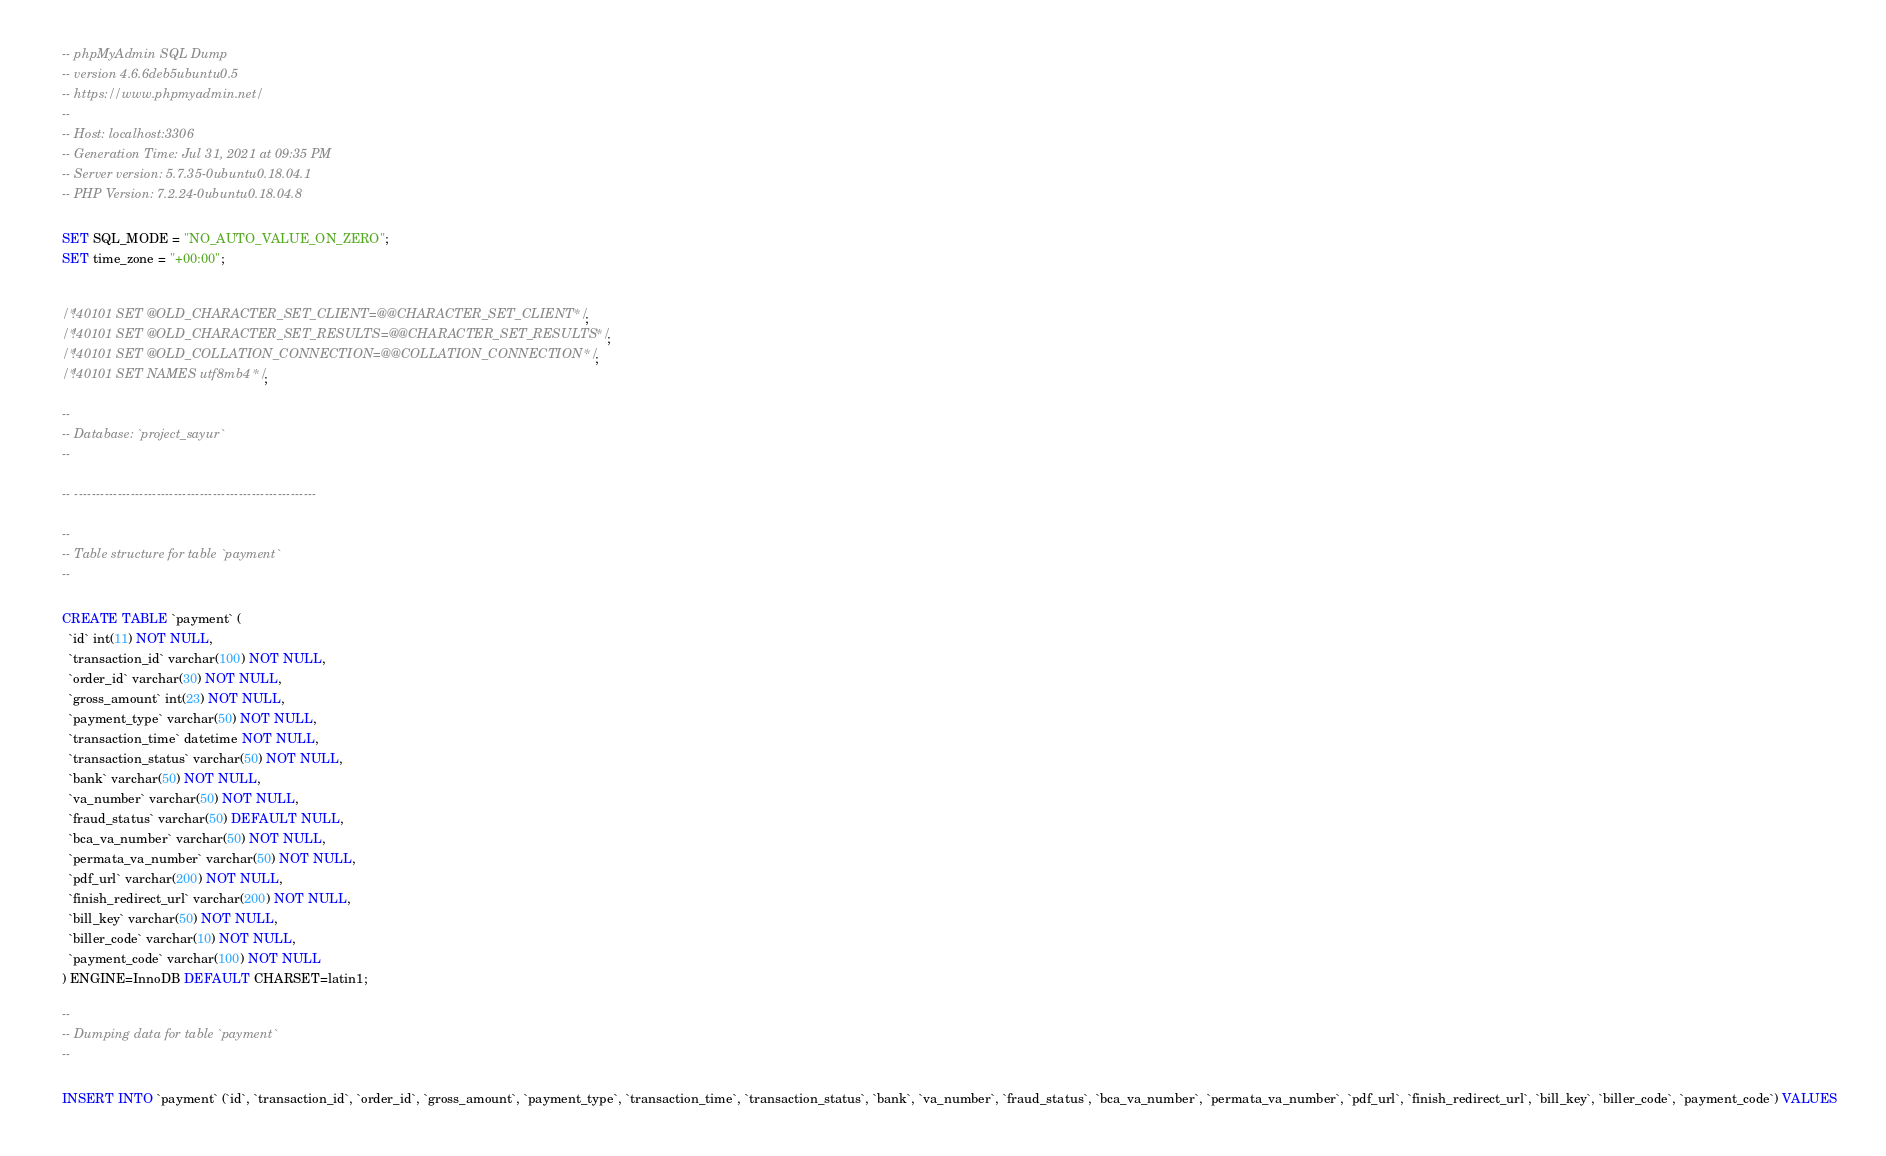Convert code to text. <code><loc_0><loc_0><loc_500><loc_500><_SQL_>-- phpMyAdmin SQL Dump
-- version 4.6.6deb5ubuntu0.5
-- https://www.phpmyadmin.net/
--
-- Host: localhost:3306
-- Generation Time: Jul 31, 2021 at 09:35 PM
-- Server version: 5.7.35-0ubuntu0.18.04.1
-- PHP Version: 7.2.24-0ubuntu0.18.04.8

SET SQL_MODE = "NO_AUTO_VALUE_ON_ZERO";
SET time_zone = "+00:00";


/*!40101 SET @OLD_CHARACTER_SET_CLIENT=@@CHARACTER_SET_CLIENT */;
/*!40101 SET @OLD_CHARACTER_SET_RESULTS=@@CHARACTER_SET_RESULTS */;
/*!40101 SET @OLD_COLLATION_CONNECTION=@@COLLATION_CONNECTION */;
/*!40101 SET NAMES utf8mb4 */;

--
-- Database: `project_sayur`
--

-- --------------------------------------------------------

--
-- Table structure for table `payment`
--

CREATE TABLE `payment` (
  `id` int(11) NOT NULL,
  `transaction_id` varchar(100) NOT NULL,
  `order_id` varchar(30) NOT NULL,
  `gross_amount` int(23) NOT NULL,
  `payment_type` varchar(50) NOT NULL,
  `transaction_time` datetime NOT NULL,
  `transaction_status` varchar(50) NOT NULL,
  `bank` varchar(50) NOT NULL,
  `va_number` varchar(50) NOT NULL,
  `fraud_status` varchar(50) DEFAULT NULL,
  `bca_va_number` varchar(50) NOT NULL,
  `permata_va_number` varchar(50) NOT NULL,
  `pdf_url` varchar(200) NOT NULL,
  `finish_redirect_url` varchar(200) NOT NULL,
  `bill_key` varchar(50) NOT NULL,
  `biller_code` varchar(10) NOT NULL,
  `payment_code` varchar(100) NOT NULL
) ENGINE=InnoDB DEFAULT CHARSET=latin1;

--
-- Dumping data for table `payment`
--

INSERT INTO `payment` (`id`, `transaction_id`, `order_id`, `gross_amount`, `payment_type`, `transaction_time`, `transaction_status`, `bank`, `va_number`, `fraud_status`, `bca_va_number`, `permata_va_number`, `pdf_url`, `finish_redirect_url`, `bill_key`, `biller_code`, `payment_code`) VALUES</code> 